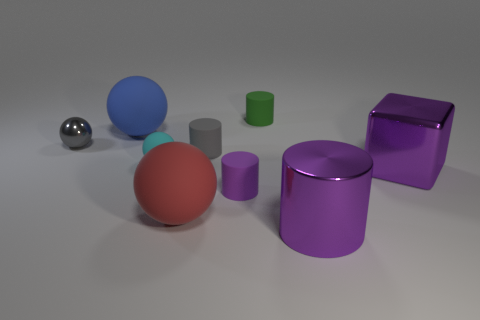Subtract all matte balls. How many balls are left? 1 Add 1 metallic things. How many objects exist? 10 Subtract all purple cylinders. How many cylinders are left? 2 Subtract 1 spheres. How many spheres are left? 3 Add 1 purple matte objects. How many purple matte objects are left? 2 Add 1 red matte things. How many red matte things exist? 2 Subtract 1 cyan balls. How many objects are left? 8 Subtract all balls. How many objects are left? 5 Subtract all gray blocks. Subtract all blue spheres. How many blocks are left? 1 Subtract all green balls. How many purple cylinders are left? 2 